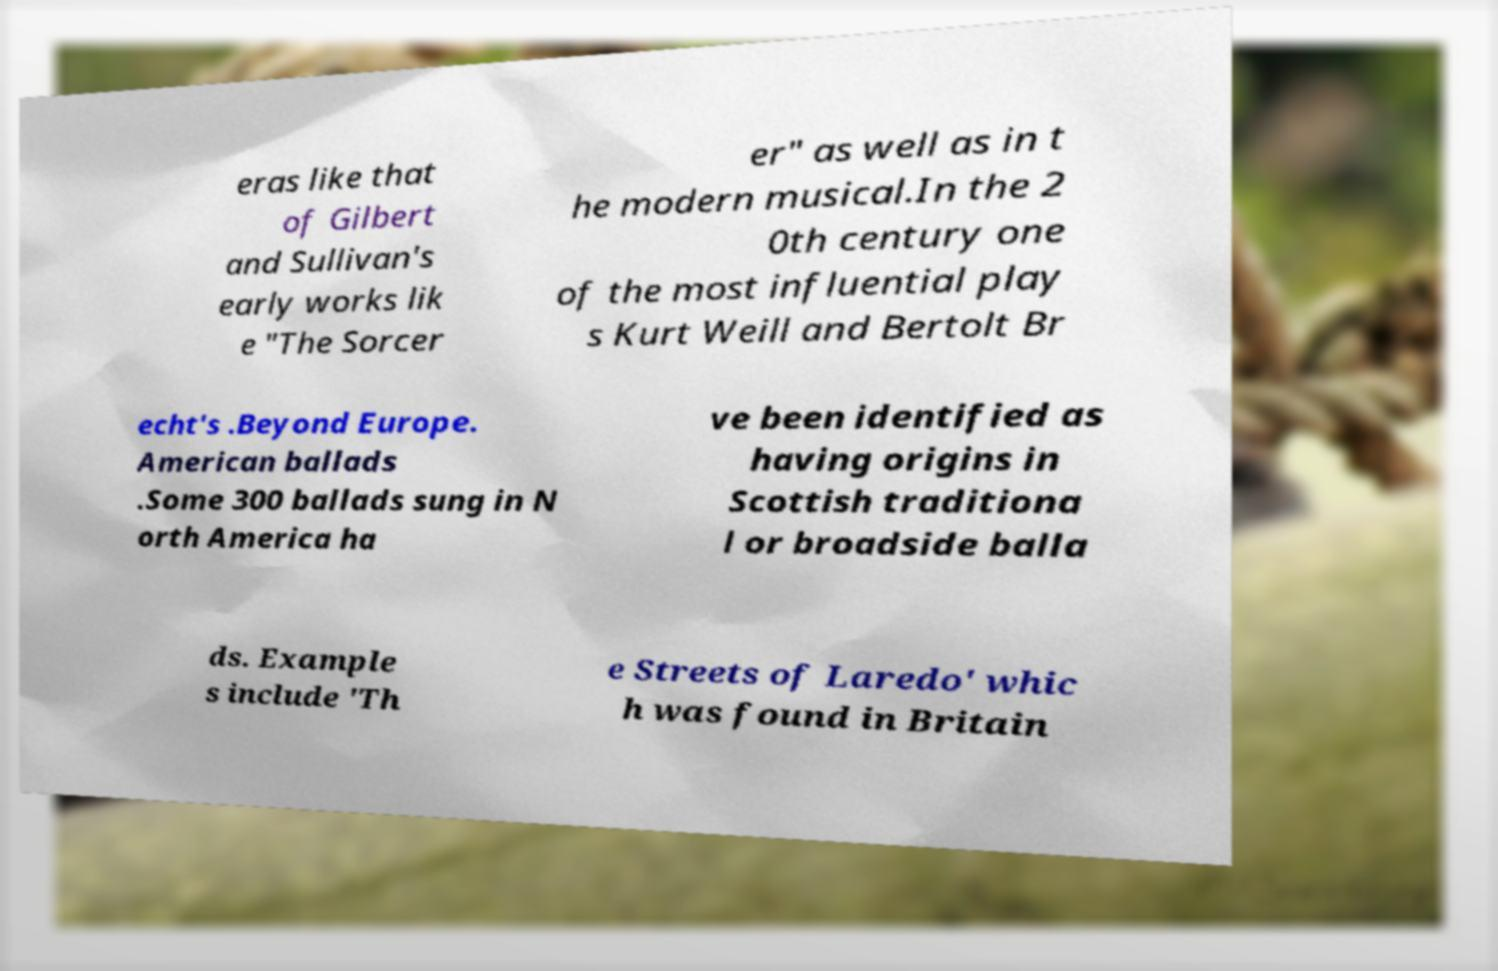Could you assist in decoding the text presented in this image and type it out clearly? eras like that of Gilbert and Sullivan's early works lik e "The Sorcer er" as well as in t he modern musical.In the 2 0th century one of the most influential play s Kurt Weill and Bertolt Br echt's .Beyond Europe. American ballads .Some 300 ballads sung in N orth America ha ve been identified as having origins in Scottish traditiona l or broadside balla ds. Example s include 'Th e Streets of Laredo' whic h was found in Britain 